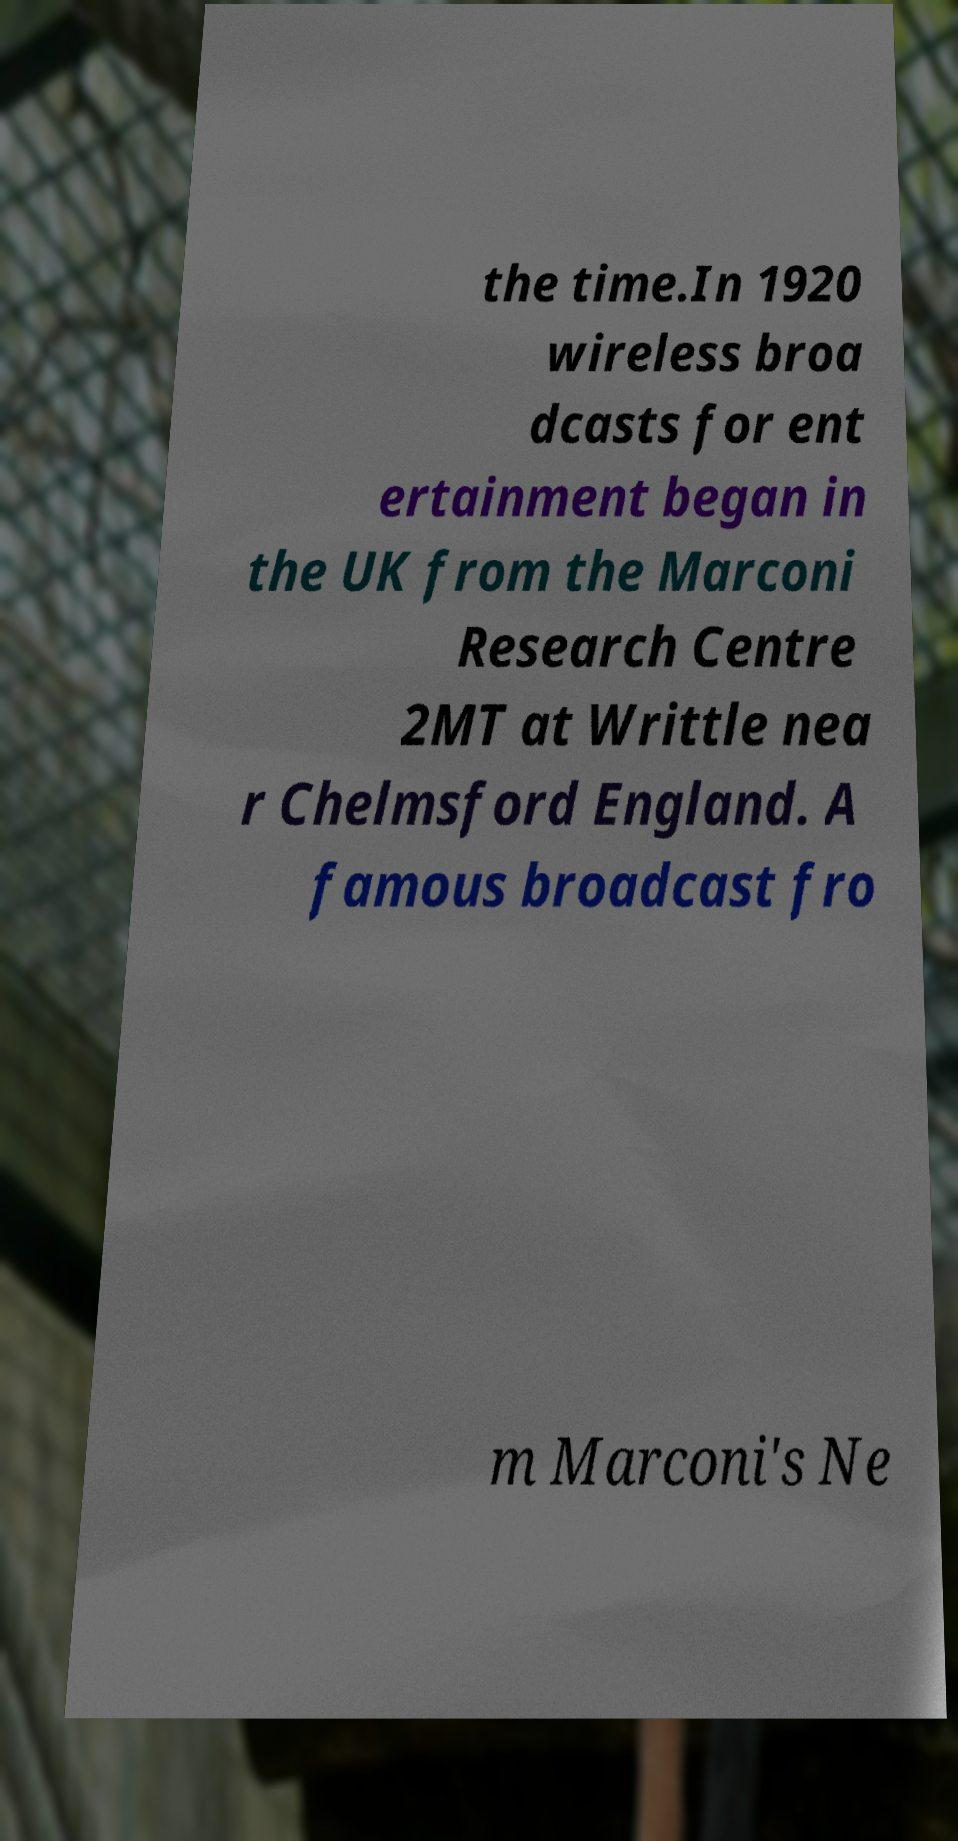Please identify and transcribe the text found in this image. the time.In 1920 wireless broa dcasts for ent ertainment began in the UK from the Marconi Research Centre 2MT at Writtle nea r Chelmsford England. A famous broadcast fro m Marconi's Ne 